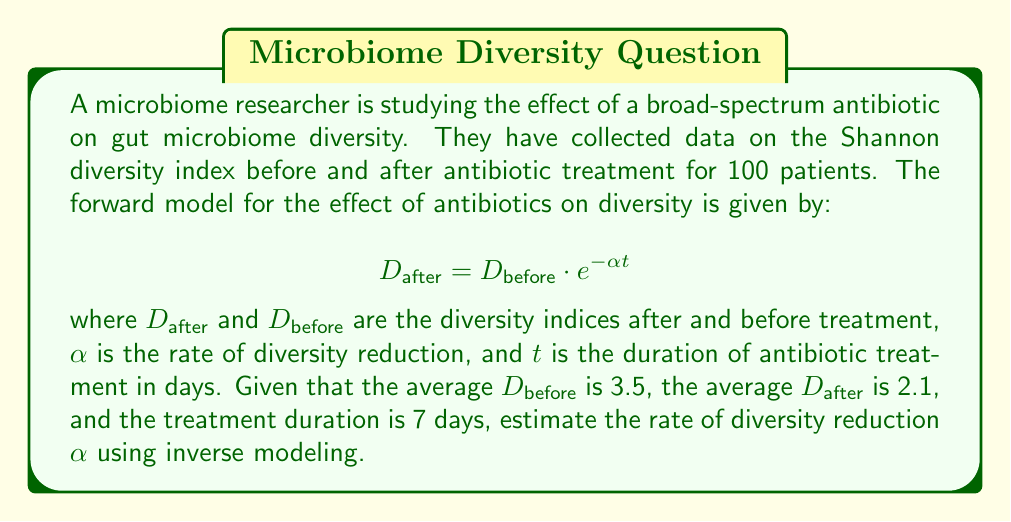Teach me how to tackle this problem. To solve this inverse problem, we need to estimate the parameter $\alpha$ given the observed data. Let's approach this step-by-step:

1) We start with the forward model:
   $$D_{\text{after}} = D_{\text{before}} \cdot e^{-\alpha t}$$

2) We know the following:
   - Average $D_{\text{before}} = 3.5$
   - Average $D_{\text{after}} = 2.1$
   - $t = 7$ days

3) Substituting these values into the equation:
   $$2.1 = 3.5 \cdot e^{-\alpha \cdot 7}$$

4) To solve for $\alpha$, we first divide both sides by 3.5:
   $$\frac{2.1}{3.5} = e^{-\alpha \cdot 7}$$

5) Take the natural logarithm of both sides:
   $$\ln(\frac{2.1}{3.5}) = -\alpha \cdot 7$$

6) Solve for $\alpha$:
   $$\alpha = -\frac{1}{7} \ln(\frac{2.1}{3.5})$$

7) Calculate the value:
   $$\alpha = -\frac{1}{7} \ln(0.6) \approx 0.0734$$

Thus, the estimated rate of diversity reduction is approximately 0.0734 per day.
Answer: $\alpha \approx 0.0734$ per day 